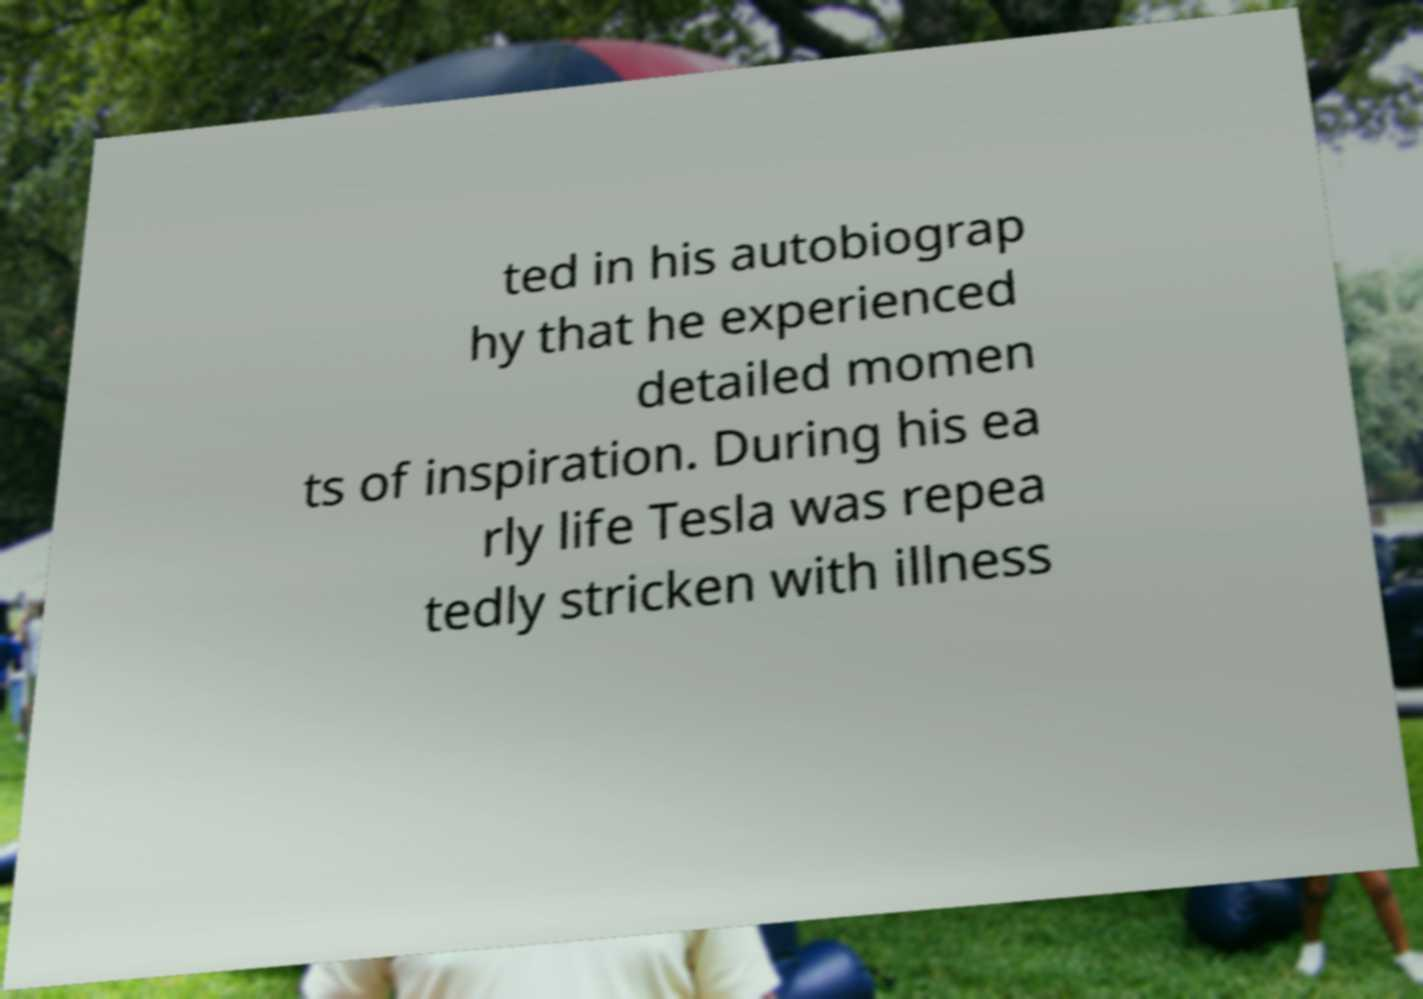I need the written content from this picture converted into text. Can you do that? ted in his autobiograp hy that he experienced detailed momen ts of inspiration. During his ea rly life Tesla was repea tedly stricken with illness 